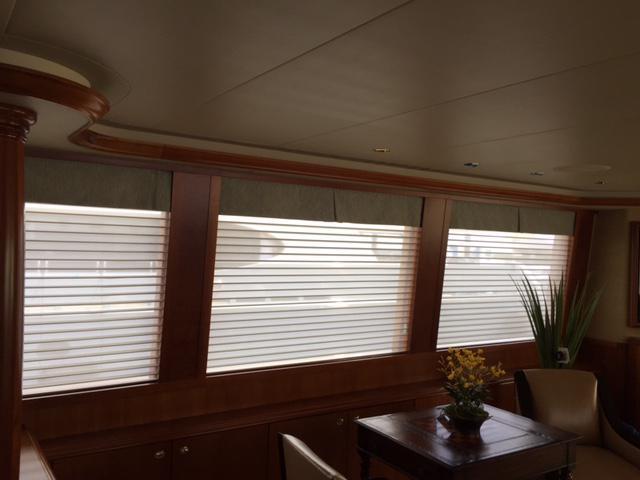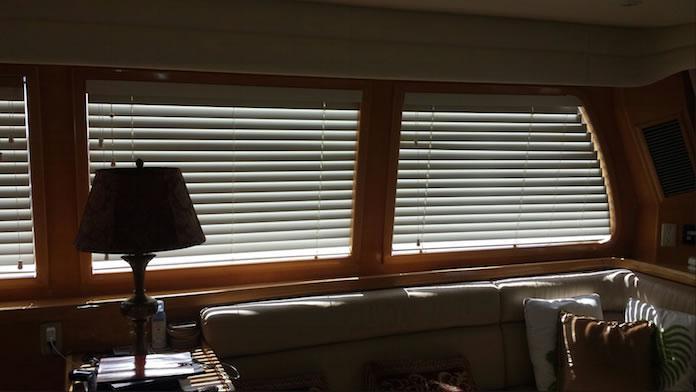The first image is the image on the left, the second image is the image on the right. For the images displayed, is the sentence "The window area in the image on the left has lights that are switched on." factually correct? Answer yes or no. No. 